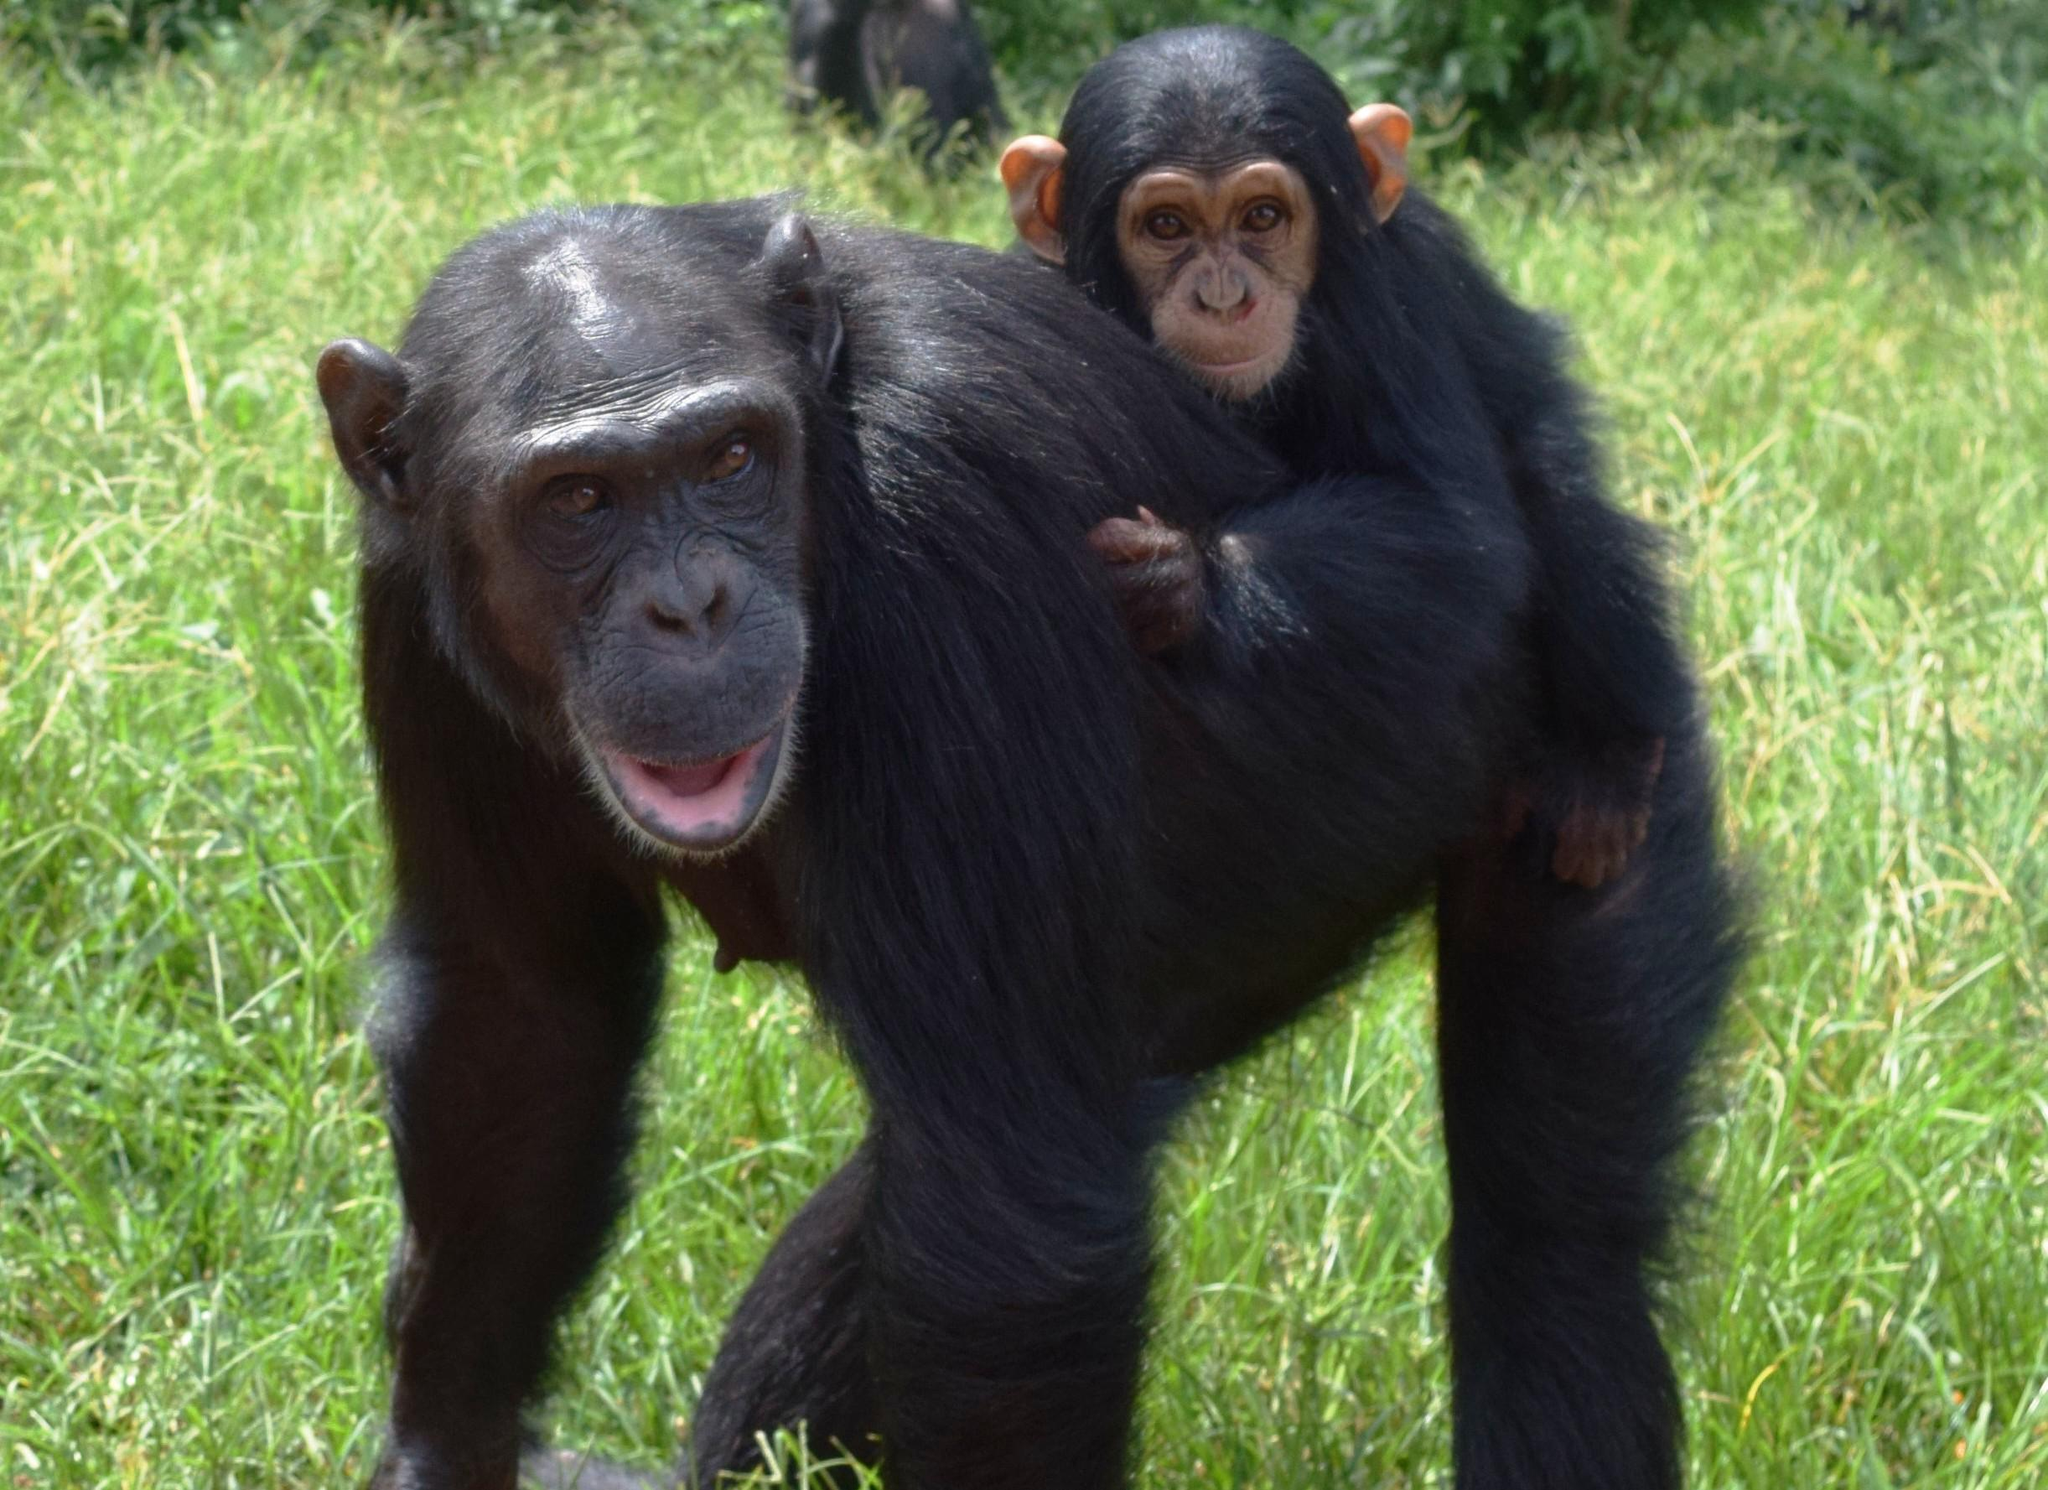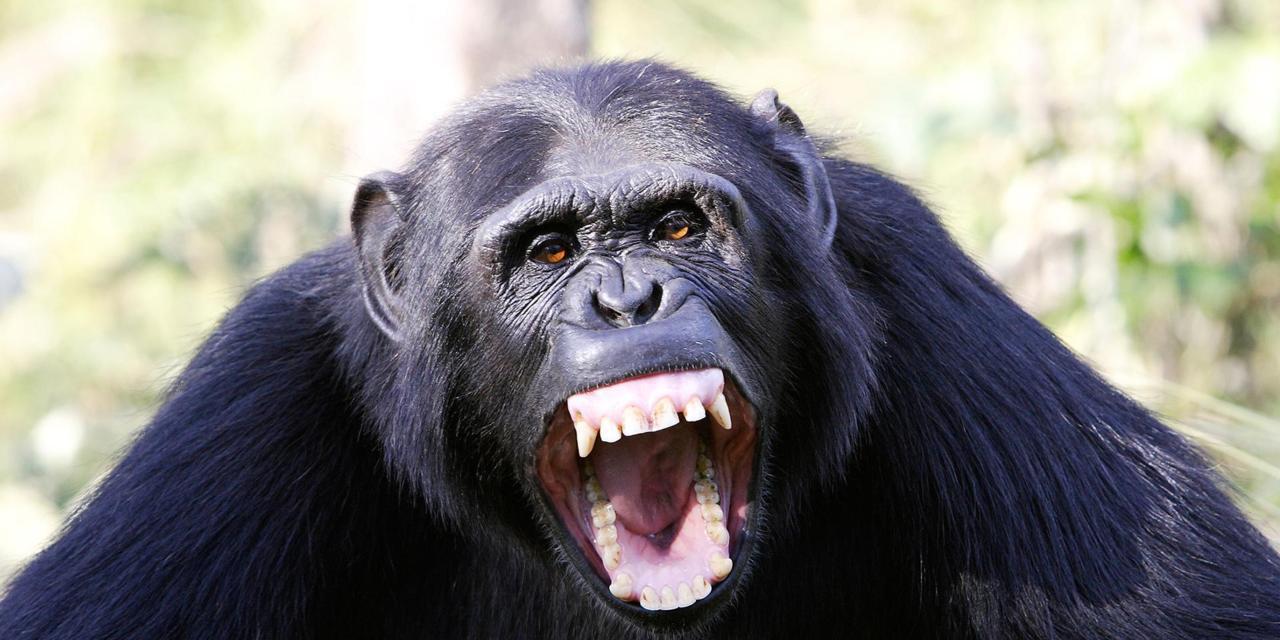The first image is the image on the left, the second image is the image on the right. For the images displayed, is the sentence "The chimp in the right image is showing his teeth." factually correct? Answer yes or no. Yes. 